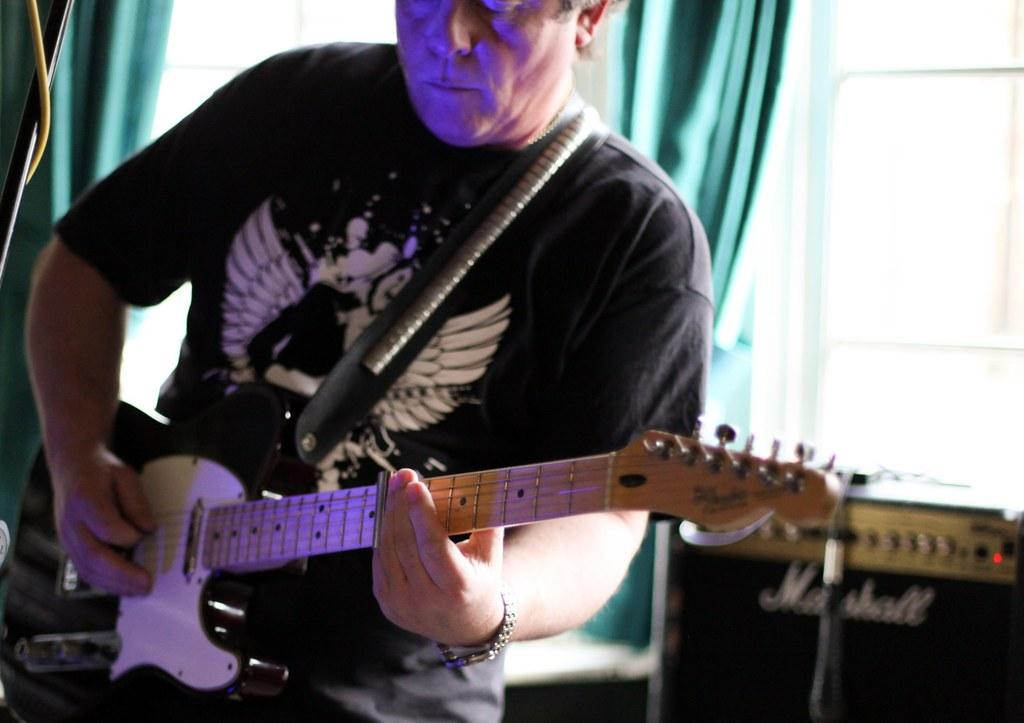Who is the main subject in the image? There is a man in the image. What is the man holding in the image? The man is holding a guitar. What is the man doing with the guitar? The man is playing the guitar. What other object can be seen in the image? There is a speaker visible in the image. What type of cork can be seen on the man's shoes in the image? There is no cork visible on the man's shoes in the image. What color is the curtain behind the man in the image? There is no curtain present in the image. 